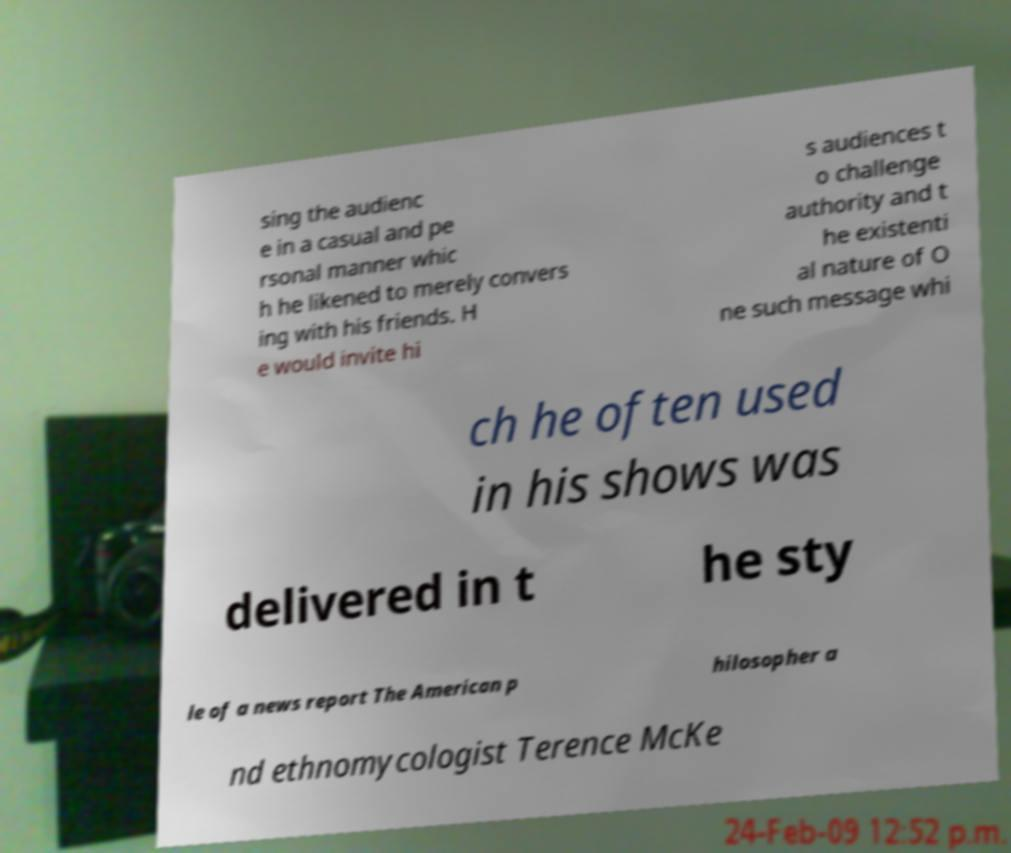Can you read and provide the text displayed in the image?This photo seems to have some interesting text. Can you extract and type it out for me? sing the audienc e in a casual and pe rsonal manner whic h he likened to merely convers ing with his friends. H e would invite hi s audiences t o challenge authority and t he existenti al nature of O ne such message whi ch he often used in his shows was delivered in t he sty le of a news report The American p hilosopher a nd ethnomycologist Terence McKe 